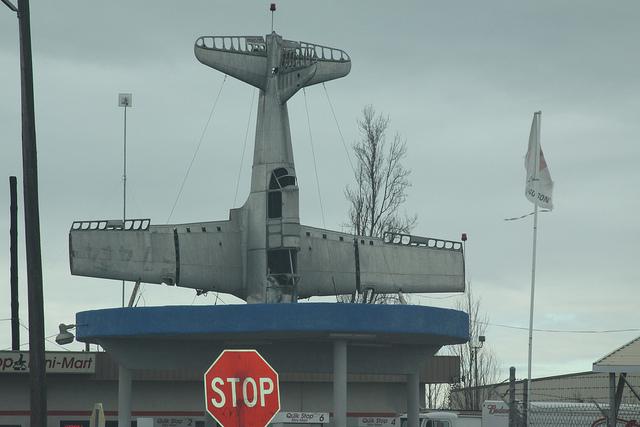Can this airplane fly?
Be succinct. No. Where is the statue located?
Keep it brief. Rooftop. Did the plane obey the stop sign?
Give a very brief answer. No. What color is the plane?
Write a very short answer. Gray. What kind of vehicle is pictured here?
Quick response, please. Airplane. What color is this airplane?
Give a very brief answer. White. What is the building made of?
Give a very brief answer. Concrete. 